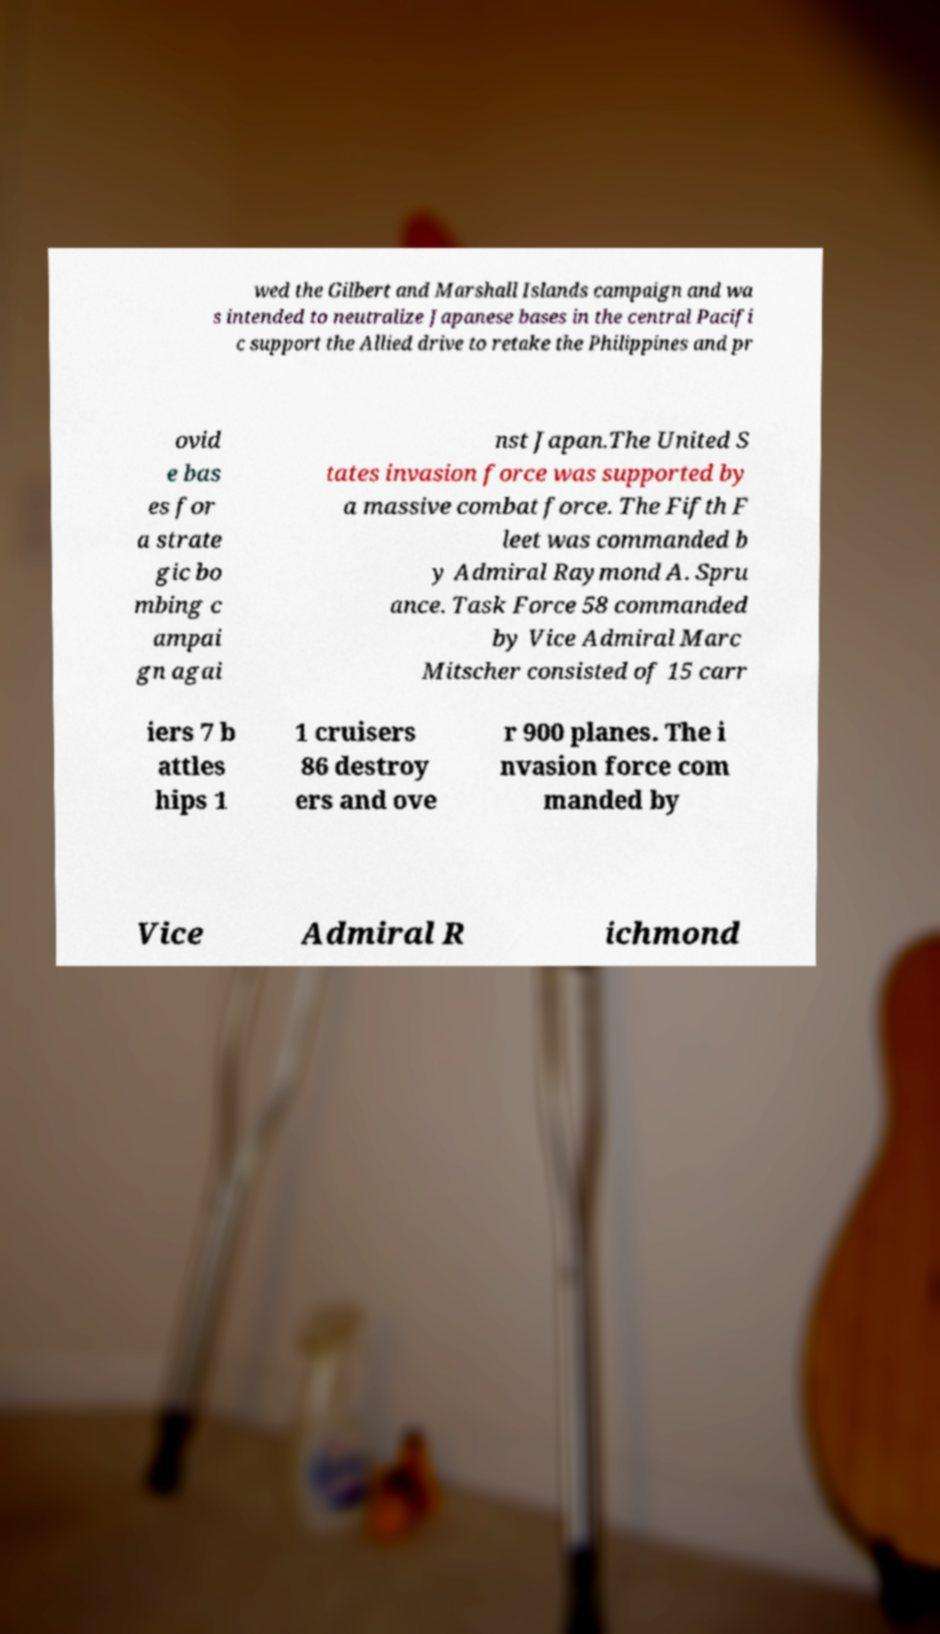Can you accurately transcribe the text from the provided image for me? wed the Gilbert and Marshall Islands campaign and wa s intended to neutralize Japanese bases in the central Pacifi c support the Allied drive to retake the Philippines and pr ovid e bas es for a strate gic bo mbing c ampai gn agai nst Japan.The United S tates invasion force was supported by a massive combat force. The Fifth F leet was commanded b y Admiral Raymond A. Spru ance. Task Force 58 commanded by Vice Admiral Marc Mitscher consisted of 15 carr iers 7 b attles hips 1 1 cruisers 86 destroy ers and ove r 900 planes. The i nvasion force com manded by Vice Admiral R ichmond 